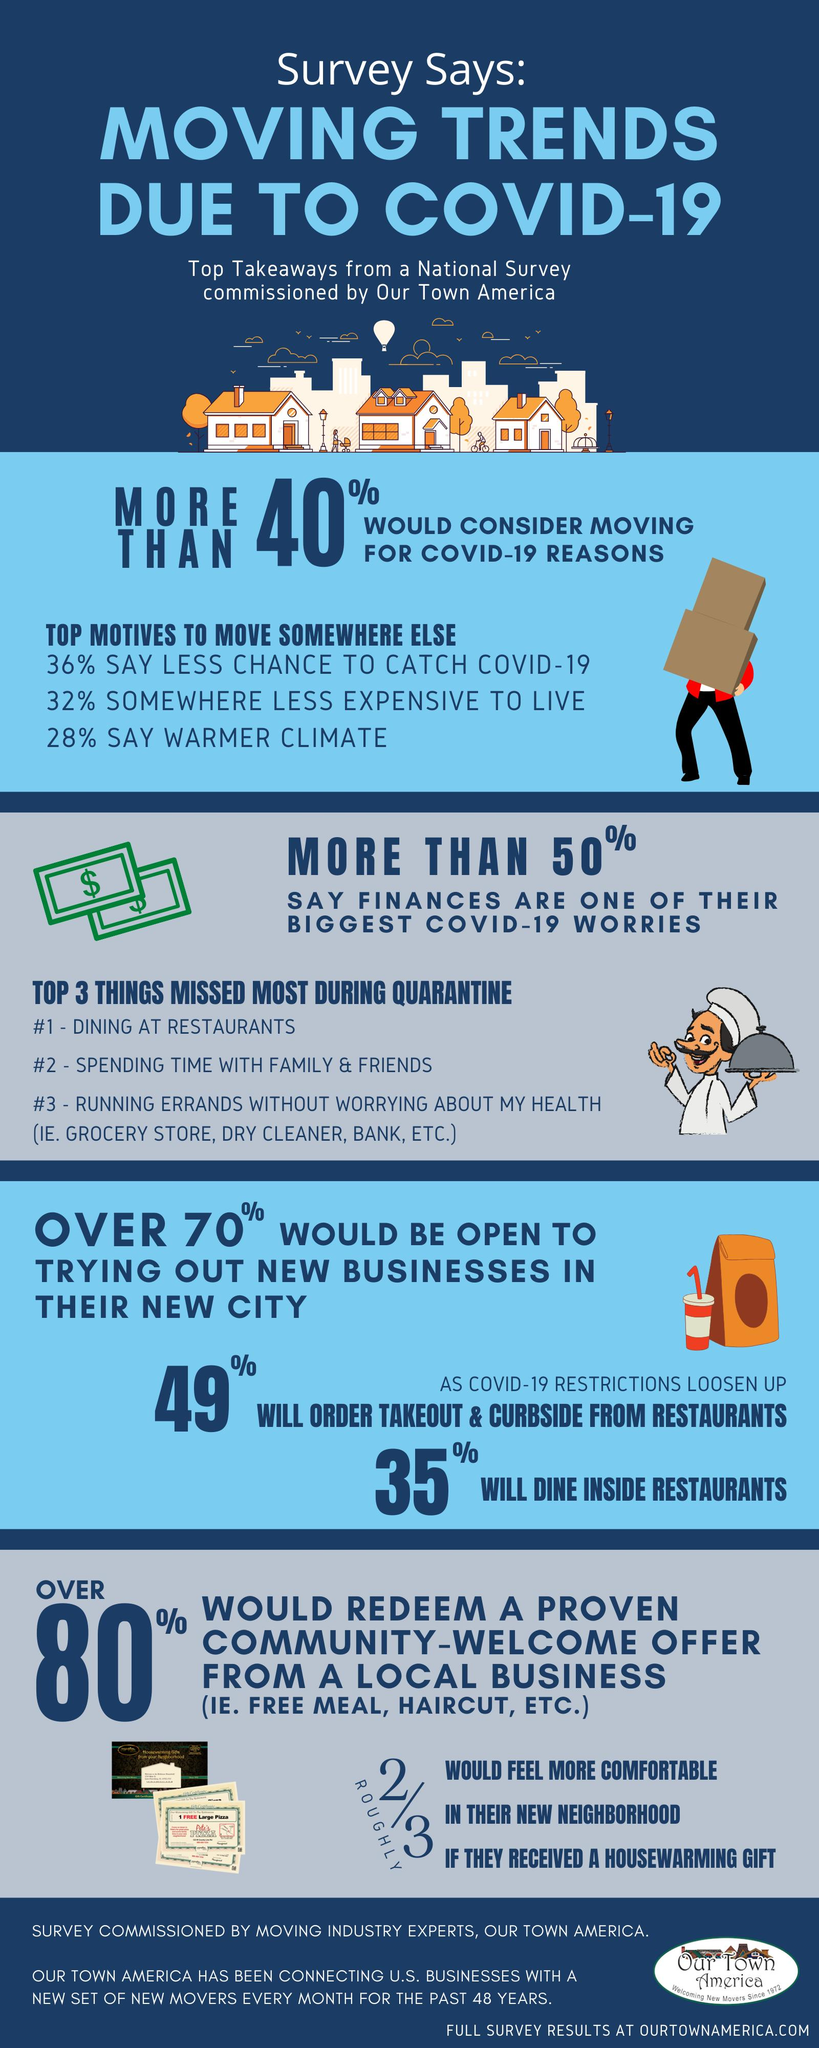Point out several critical features in this image. As a result of COVID-19 and climate-related reasons, a total of 64% of people were affected. The COVID-19 pandemic or financial reasons were the primary reasons why more people decided to move to a different location, as they sought to save themselves from its impact. In total, 68% of people were moved due to COVID-19 related reasons or financial reasons. Sixty percent of the people were moved due to climate-related reasons or financial reasons. During the COVID-19 pandemic, the second most missed thing has been spending time with family and friends. 